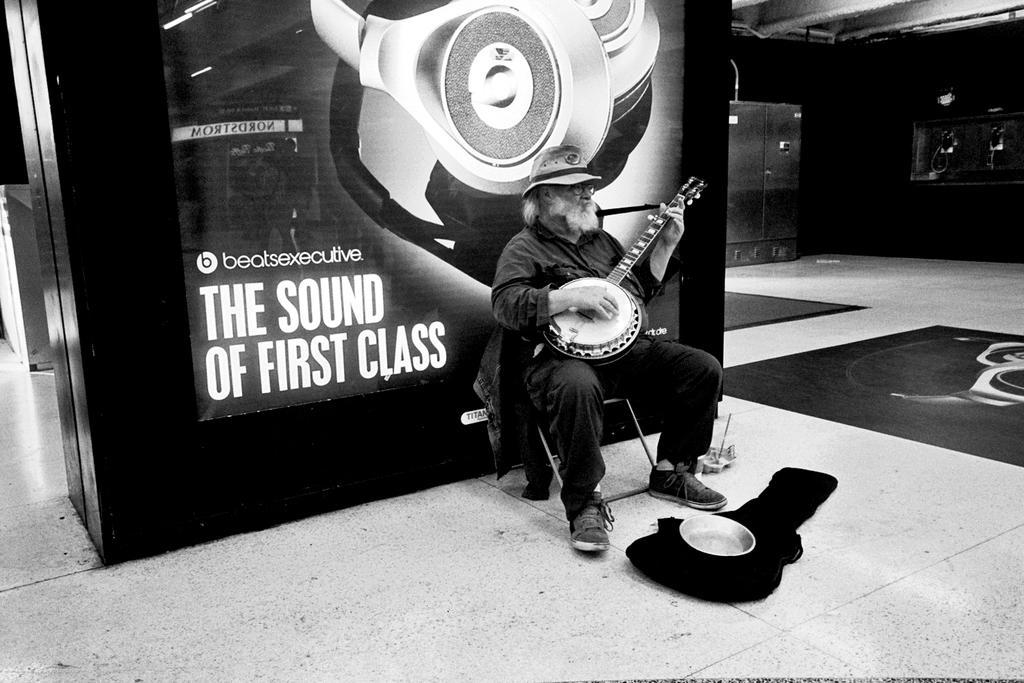Describe this image in one or two sentences. In the picture I can see a man is sitting on a chair and playing a musical instrument. The man is wearing a hat. Here I can see bag and some other objects on the floor. In the background I can see a wall on which there is a picture of an object and something written on it. This picture is black and white in color. 